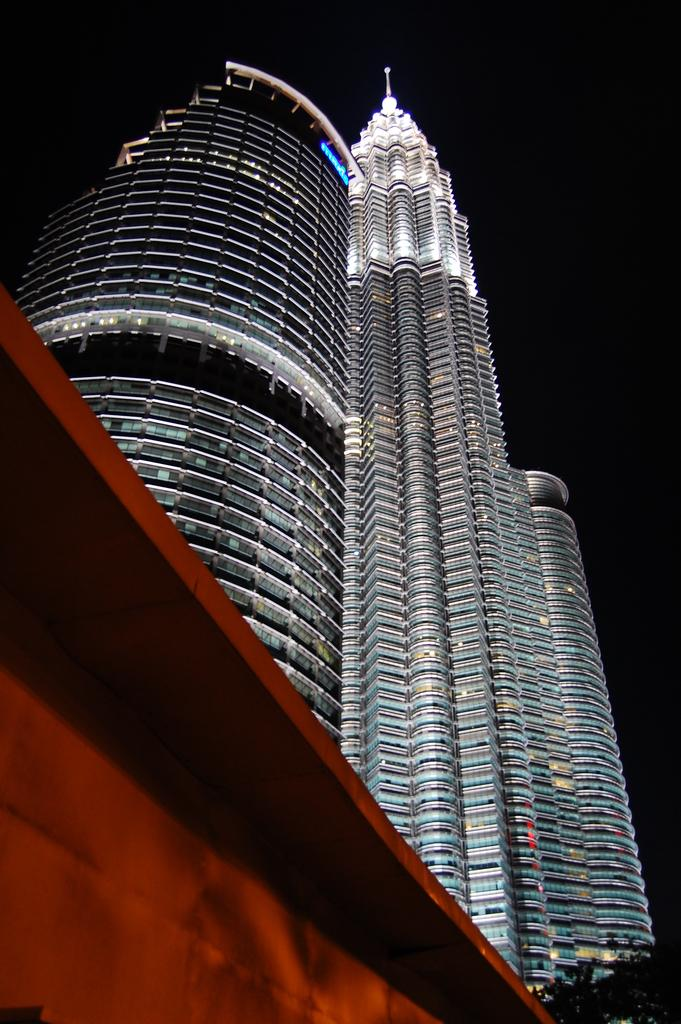What is the main subject in the center of the image? There are buildings in the center of the image. What can be seen in the front of the image? There is an object in the front of the image. What is the color of the object in the front? The object is red in color. How many sticks of cabbage can be seen in the image? There are no sticks of cabbage present in the image. Is the doctor in the image performing a checkup on the buildings? There is no doctor or any indication of a checkup in the image; it features buildings and an object in the front. 